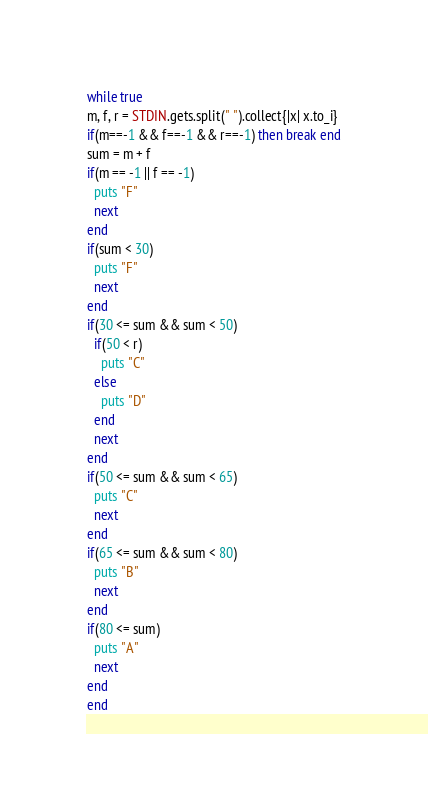Convert code to text. <code><loc_0><loc_0><loc_500><loc_500><_Ruby_>while true
m, f, r = STDIN.gets.split(" ").collect{|x| x.to_i}
if(m==-1 && f==-1 && r==-1) then break end
sum = m + f
if(m == -1 || f == -1)
  puts "F"
  next
end
if(sum < 30)
  puts "F"
  next
end
if(30 <= sum && sum < 50)
  if(50 < r)
    puts "C"
  else
    puts "D"
  end
  next
end
if(50 <= sum && sum < 65)
  puts "C"
  next
end
if(65 <= sum && sum < 80)
  puts "B"
  next
end
if(80 <= sum)
  puts "A"
  next
end
end</code> 